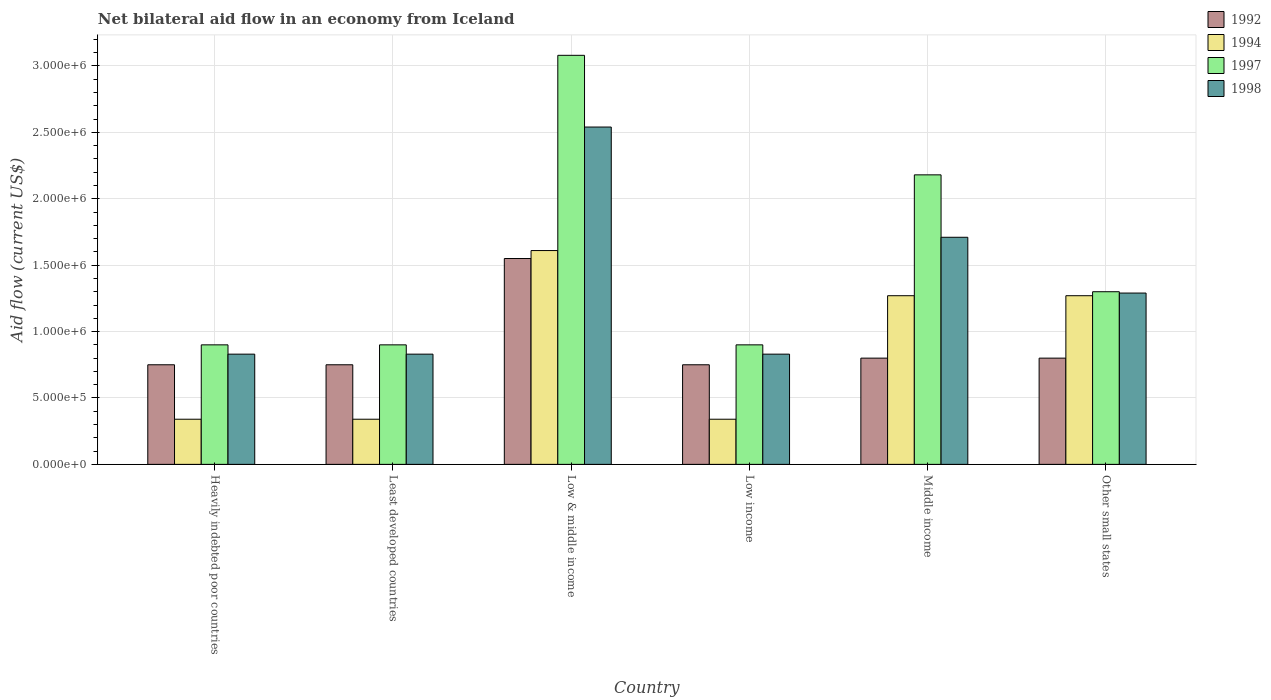How many groups of bars are there?
Your answer should be compact. 6. Are the number of bars per tick equal to the number of legend labels?
Offer a very short reply. Yes. How many bars are there on the 3rd tick from the left?
Your answer should be very brief. 4. What is the label of the 6th group of bars from the left?
Ensure brevity in your answer.  Other small states. What is the net bilateral aid flow in 1994 in Low income?
Make the answer very short. 3.40e+05. Across all countries, what is the maximum net bilateral aid flow in 1998?
Offer a very short reply. 2.54e+06. Across all countries, what is the minimum net bilateral aid flow in 1998?
Your response must be concise. 8.30e+05. In which country was the net bilateral aid flow in 1994 maximum?
Provide a short and direct response. Low & middle income. In which country was the net bilateral aid flow in 1997 minimum?
Keep it short and to the point. Heavily indebted poor countries. What is the total net bilateral aid flow in 1994 in the graph?
Offer a terse response. 5.17e+06. What is the difference between the net bilateral aid flow in 1992 in Heavily indebted poor countries and that in Other small states?
Offer a terse response. -5.00e+04. What is the difference between the net bilateral aid flow in 1997 in Low & middle income and the net bilateral aid flow in 1992 in Least developed countries?
Make the answer very short. 2.33e+06. What is the average net bilateral aid flow in 1997 per country?
Provide a short and direct response. 1.54e+06. What is the difference between the net bilateral aid flow of/in 1994 and net bilateral aid flow of/in 1997 in Low & middle income?
Provide a succinct answer. -1.47e+06. In how many countries, is the net bilateral aid flow in 1998 greater than 200000 US$?
Your response must be concise. 6. What is the ratio of the net bilateral aid flow in 1994 in Heavily indebted poor countries to that in Low & middle income?
Your answer should be very brief. 0.21. Is the difference between the net bilateral aid flow in 1994 in Least developed countries and Low & middle income greater than the difference between the net bilateral aid flow in 1997 in Least developed countries and Low & middle income?
Provide a short and direct response. Yes. What is the difference between the highest and the second highest net bilateral aid flow in 1997?
Your response must be concise. 1.78e+06. What is the difference between the highest and the lowest net bilateral aid flow in 1997?
Your response must be concise. 2.18e+06. In how many countries, is the net bilateral aid flow in 1997 greater than the average net bilateral aid flow in 1997 taken over all countries?
Your response must be concise. 2. Is the sum of the net bilateral aid flow in 1992 in Low income and Other small states greater than the maximum net bilateral aid flow in 1998 across all countries?
Provide a short and direct response. No. Is it the case that in every country, the sum of the net bilateral aid flow in 1992 and net bilateral aid flow in 1994 is greater than the sum of net bilateral aid flow in 1998 and net bilateral aid flow in 1997?
Make the answer very short. No. What does the 2nd bar from the right in Low income represents?
Your response must be concise. 1997. Is it the case that in every country, the sum of the net bilateral aid flow in 1994 and net bilateral aid flow in 1992 is greater than the net bilateral aid flow in 1997?
Offer a very short reply. No. How many bars are there?
Provide a short and direct response. 24. Are all the bars in the graph horizontal?
Your answer should be compact. No. What is the difference between two consecutive major ticks on the Y-axis?
Give a very brief answer. 5.00e+05. Are the values on the major ticks of Y-axis written in scientific E-notation?
Your answer should be very brief. Yes. Does the graph contain any zero values?
Provide a short and direct response. No. How are the legend labels stacked?
Provide a short and direct response. Vertical. What is the title of the graph?
Offer a terse response. Net bilateral aid flow in an economy from Iceland. Does "2002" appear as one of the legend labels in the graph?
Your answer should be very brief. No. What is the label or title of the X-axis?
Your answer should be very brief. Country. What is the Aid flow (current US$) of 1992 in Heavily indebted poor countries?
Offer a very short reply. 7.50e+05. What is the Aid flow (current US$) of 1997 in Heavily indebted poor countries?
Offer a very short reply. 9.00e+05. What is the Aid flow (current US$) in 1998 in Heavily indebted poor countries?
Offer a very short reply. 8.30e+05. What is the Aid flow (current US$) of 1992 in Least developed countries?
Your response must be concise. 7.50e+05. What is the Aid flow (current US$) in 1994 in Least developed countries?
Your answer should be compact. 3.40e+05. What is the Aid flow (current US$) in 1998 in Least developed countries?
Provide a short and direct response. 8.30e+05. What is the Aid flow (current US$) of 1992 in Low & middle income?
Make the answer very short. 1.55e+06. What is the Aid flow (current US$) in 1994 in Low & middle income?
Keep it short and to the point. 1.61e+06. What is the Aid flow (current US$) in 1997 in Low & middle income?
Ensure brevity in your answer.  3.08e+06. What is the Aid flow (current US$) in 1998 in Low & middle income?
Give a very brief answer. 2.54e+06. What is the Aid flow (current US$) of 1992 in Low income?
Give a very brief answer. 7.50e+05. What is the Aid flow (current US$) of 1994 in Low income?
Keep it short and to the point. 3.40e+05. What is the Aid flow (current US$) of 1998 in Low income?
Offer a very short reply. 8.30e+05. What is the Aid flow (current US$) of 1994 in Middle income?
Make the answer very short. 1.27e+06. What is the Aid flow (current US$) in 1997 in Middle income?
Your response must be concise. 2.18e+06. What is the Aid flow (current US$) of 1998 in Middle income?
Provide a succinct answer. 1.71e+06. What is the Aid flow (current US$) in 1994 in Other small states?
Your answer should be compact. 1.27e+06. What is the Aid flow (current US$) of 1997 in Other small states?
Offer a very short reply. 1.30e+06. What is the Aid flow (current US$) of 1998 in Other small states?
Provide a succinct answer. 1.29e+06. Across all countries, what is the maximum Aid flow (current US$) in 1992?
Your response must be concise. 1.55e+06. Across all countries, what is the maximum Aid flow (current US$) in 1994?
Your answer should be very brief. 1.61e+06. Across all countries, what is the maximum Aid flow (current US$) of 1997?
Offer a terse response. 3.08e+06. Across all countries, what is the maximum Aid flow (current US$) in 1998?
Your response must be concise. 2.54e+06. Across all countries, what is the minimum Aid flow (current US$) of 1992?
Offer a terse response. 7.50e+05. Across all countries, what is the minimum Aid flow (current US$) of 1994?
Offer a terse response. 3.40e+05. Across all countries, what is the minimum Aid flow (current US$) in 1997?
Provide a succinct answer. 9.00e+05. Across all countries, what is the minimum Aid flow (current US$) in 1998?
Keep it short and to the point. 8.30e+05. What is the total Aid flow (current US$) in 1992 in the graph?
Provide a short and direct response. 5.40e+06. What is the total Aid flow (current US$) in 1994 in the graph?
Offer a terse response. 5.17e+06. What is the total Aid flow (current US$) in 1997 in the graph?
Your response must be concise. 9.26e+06. What is the total Aid flow (current US$) of 1998 in the graph?
Give a very brief answer. 8.03e+06. What is the difference between the Aid flow (current US$) in 1994 in Heavily indebted poor countries and that in Least developed countries?
Provide a succinct answer. 0. What is the difference between the Aid flow (current US$) in 1998 in Heavily indebted poor countries and that in Least developed countries?
Give a very brief answer. 0. What is the difference between the Aid flow (current US$) of 1992 in Heavily indebted poor countries and that in Low & middle income?
Offer a terse response. -8.00e+05. What is the difference between the Aid flow (current US$) of 1994 in Heavily indebted poor countries and that in Low & middle income?
Your response must be concise. -1.27e+06. What is the difference between the Aid flow (current US$) of 1997 in Heavily indebted poor countries and that in Low & middle income?
Offer a very short reply. -2.18e+06. What is the difference between the Aid flow (current US$) in 1998 in Heavily indebted poor countries and that in Low & middle income?
Your answer should be compact. -1.71e+06. What is the difference between the Aid flow (current US$) in 1997 in Heavily indebted poor countries and that in Low income?
Offer a very short reply. 0. What is the difference between the Aid flow (current US$) of 1998 in Heavily indebted poor countries and that in Low income?
Provide a succinct answer. 0. What is the difference between the Aid flow (current US$) of 1994 in Heavily indebted poor countries and that in Middle income?
Make the answer very short. -9.30e+05. What is the difference between the Aid flow (current US$) of 1997 in Heavily indebted poor countries and that in Middle income?
Provide a succinct answer. -1.28e+06. What is the difference between the Aid flow (current US$) in 1998 in Heavily indebted poor countries and that in Middle income?
Make the answer very short. -8.80e+05. What is the difference between the Aid flow (current US$) in 1994 in Heavily indebted poor countries and that in Other small states?
Make the answer very short. -9.30e+05. What is the difference between the Aid flow (current US$) of 1997 in Heavily indebted poor countries and that in Other small states?
Your answer should be very brief. -4.00e+05. What is the difference between the Aid flow (current US$) in 1998 in Heavily indebted poor countries and that in Other small states?
Ensure brevity in your answer.  -4.60e+05. What is the difference between the Aid flow (current US$) of 1992 in Least developed countries and that in Low & middle income?
Provide a succinct answer. -8.00e+05. What is the difference between the Aid flow (current US$) of 1994 in Least developed countries and that in Low & middle income?
Make the answer very short. -1.27e+06. What is the difference between the Aid flow (current US$) of 1997 in Least developed countries and that in Low & middle income?
Provide a succinct answer. -2.18e+06. What is the difference between the Aid flow (current US$) of 1998 in Least developed countries and that in Low & middle income?
Your response must be concise. -1.71e+06. What is the difference between the Aid flow (current US$) of 1994 in Least developed countries and that in Low income?
Give a very brief answer. 0. What is the difference between the Aid flow (current US$) of 1998 in Least developed countries and that in Low income?
Keep it short and to the point. 0. What is the difference between the Aid flow (current US$) in 1994 in Least developed countries and that in Middle income?
Offer a very short reply. -9.30e+05. What is the difference between the Aid flow (current US$) in 1997 in Least developed countries and that in Middle income?
Ensure brevity in your answer.  -1.28e+06. What is the difference between the Aid flow (current US$) in 1998 in Least developed countries and that in Middle income?
Provide a succinct answer. -8.80e+05. What is the difference between the Aid flow (current US$) in 1992 in Least developed countries and that in Other small states?
Provide a succinct answer. -5.00e+04. What is the difference between the Aid flow (current US$) of 1994 in Least developed countries and that in Other small states?
Provide a short and direct response. -9.30e+05. What is the difference between the Aid flow (current US$) in 1997 in Least developed countries and that in Other small states?
Your answer should be compact. -4.00e+05. What is the difference between the Aid flow (current US$) of 1998 in Least developed countries and that in Other small states?
Offer a terse response. -4.60e+05. What is the difference between the Aid flow (current US$) in 1992 in Low & middle income and that in Low income?
Ensure brevity in your answer.  8.00e+05. What is the difference between the Aid flow (current US$) in 1994 in Low & middle income and that in Low income?
Make the answer very short. 1.27e+06. What is the difference between the Aid flow (current US$) in 1997 in Low & middle income and that in Low income?
Make the answer very short. 2.18e+06. What is the difference between the Aid flow (current US$) of 1998 in Low & middle income and that in Low income?
Your answer should be compact. 1.71e+06. What is the difference between the Aid flow (current US$) in 1992 in Low & middle income and that in Middle income?
Keep it short and to the point. 7.50e+05. What is the difference between the Aid flow (current US$) in 1994 in Low & middle income and that in Middle income?
Keep it short and to the point. 3.40e+05. What is the difference between the Aid flow (current US$) in 1997 in Low & middle income and that in Middle income?
Your answer should be compact. 9.00e+05. What is the difference between the Aid flow (current US$) of 1998 in Low & middle income and that in Middle income?
Your answer should be very brief. 8.30e+05. What is the difference between the Aid flow (current US$) of 1992 in Low & middle income and that in Other small states?
Your answer should be compact. 7.50e+05. What is the difference between the Aid flow (current US$) of 1994 in Low & middle income and that in Other small states?
Offer a terse response. 3.40e+05. What is the difference between the Aid flow (current US$) in 1997 in Low & middle income and that in Other small states?
Provide a short and direct response. 1.78e+06. What is the difference between the Aid flow (current US$) of 1998 in Low & middle income and that in Other small states?
Make the answer very short. 1.25e+06. What is the difference between the Aid flow (current US$) of 1992 in Low income and that in Middle income?
Ensure brevity in your answer.  -5.00e+04. What is the difference between the Aid flow (current US$) of 1994 in Low income and that in Middle income?
Your answer should be very brief. -9.30e+05. What is the difference between the Aid flow (current US$) of 1997 in Low income and that in Middle income?
Provide a succinct answer. -1.28e+06. What is the difference between the Aid flow (current US$) in 1998 in Low income and that in Middle income?
Give a very brief answer. -8.80e+05. What is the difference between the Aid flow (current US$) of 1994 in Low income and that in Other small states?
Offer a terse response. -9.30e+05. What is the difference between the Aid flow (current US$) in 1997 in Low income and that in Other small states?
Make the answer very short. -4.00e+05. What is the difference between the Aid flow (current US$) of 1998 in Low income and that in Other small states?
Provide a succinct answer. -4.60e+05. What is the difference between the Aid flow (current US$) of 1992 in Middle income and that in Other small states?
Your response must be concise. 0. What is the difference between the Aid flow (current US$) of 1997 in Middle income and that in Other small states?
Offer a terse response. 8.80e+05. What is the difference between the Aid flow (current US$) of 1994 in Heavily indebted poor countries and the Aid flow (current US$) of 1997 in Least developed countries?
Provide a short and direct response. -5.60e+05. What is the difference between the Aid flow (current US$) of 1994 in Heavily indebted poor countries and the Aid flow (current US$) of 1998 in Least developed countries?
Provide a succinct answer. -4.90e+05. What is the difference between the Aid flow (current US$) in 1992 in Heavily indebted poor countries and the Aid flow (current US$) in 1994 in Low & middle income?
Keep it short and to the point. -8.60e+05. What is the difference between the Aid flow (current US$) of 1992 in Heavily indebted poor countries and the Aid flow (current US$) of 1997 in Low & middle income?
Your response must be concise. -2.33e+06. What is the difference between the Aid flow (current US$) in 1992 in Heavily indebted poor countries and the Aid flow (current US$) in 1998 in Low & middle income?
Keep it short and to the point. -1.79e+06. What is the difference between the Aid flow (current US$) of 1994 in Heavily indebted poor countries and the Aid flow (current US$) of 1997 in Low & middle income?
Your answer should be compact. -2.74e+06. What is the difference between the Aid flow (current US$) in 1994 in Heavily indebted poor countries and the Aid flow (current US$) in 1998 in Low & middle income?
Make the answer very short. -2.20e+06. What is the difference between the Aid flow (current US$) of 1997 in Heavily indebted poor countries and the Aid flow (current US$) of 1998 in Low & middle income?
Ensure brevity in your answer.  -1.64e+06. What is the difference between the Aid flow (current US$) of 1992 in Heavily indebted poor countries and the Aid flow (current US$) of 1997 in Low income?
Offer a terse response. -1.50e+05. What is the difference between the Aid flow (current US$) of 1992 in Heavily indebted poor countries and the Aid flow (current US$) of 1998 in Low income?
Offer a very short reply. -8.00e+04. What is the difference between the Aid flow (current US$) of 1994 in Heavily indebted poor countries and the Aid flow (current US$) of 1997 in Low income?
Your answer should be very brief. -5.60e+05. What is the difference between the Aid flow (current US$) in 1994 in Heavily indebted poor countries and the Aid flow (current US$) in 1998 in Low income?
Keep it short and to the point. -4.90e+05. What is the difference between the Aid flow (current US$) in 1997 in Heavily indebted poor countries and the Aid flow (current US$) in 1998 in Low income?
Your answer should be compact. 7.00e+04. What is the difference between the Aid flow (current US$) of 1992 in Heavily indebted poor countries and the Aid flow (current US$) of 1994 in Middle income?
Provide a succinct answer. -5.20e+05. What is the difference between the Aid flow (current US$) of 1992 in Heavily indebted poor countries and the Aid flow (current US$) of 1997 in Middle income?
Your answer should be compact. -1.43e+06. What is the difference between the Aid flow (current US$) of 1992 in Heavily indebted poor countries and the Aid flow (current US$) of 1998 in Middle income?
Your response must be concise. -9.60e+05. What is the difference between the Aid flow (current US$) of 1994 in Heavily indebted poor countries and the Aid flow (current US$) of 1997 in Middle income?
Your answer should be very brief. -1.84e+06. What is the difference between the Aid flow (current US$) in 1994 in Heavily indebted poor countries and the Aid flow (current US$) in 1998 in Middle income?
Make the answer very short. -1.37e+06. What is the difference between the Aid flow (current US$) of 1997 in Heavily indebted poor countries and the Aid flow (current US$) of 1998 in Middle income?
Give a very brief answer. -8.10e+05. What is the difference between the Aid flow (current US$) in 1992 in Heavily indebted poor countries and the Aid flow (current US$) in 1994 in Other small states?
Provide a short and direct response. -5.20e+05. What is the difference between the Aid flow (current US$) in 1992 in Heavily indebted poor countries and the Aid flow (current US$) in 1997 in Other small states?
Keep it short and to the point. -5.50e+05. What is the difference between the Aid flow (current US$) in 1992 in Heavily indebted poor countries and the Aid flow (current US$) in 1998 in Other small states?
Your response must be concise. -5.40e+05. What is the difference between the Aid flow (current US$) of 1994 in Heavily indebted poor countries and the Aid flow (current US$) of 1997 in Other small states?
Offer a terse response. -9.60e+05. What is the difference between the Aid flow (current US$) in 1994 in Heavily indebted poor countries and the Aid flow (current US$) in 1998 in Other small states?
Make the answer very short. -9.50e+05. What is the difference between the Aid flow (current US$) in 1997 in Heavily indebted poor countries and the Aid flow (current US$) in 1998 in Other small states?
Make the answer very short. -3.90e+05. What is the difference between the Aid flow (current US$) in 1992 in Least developed countries and the Aid flow (current US$) in 1994 in Low & middle income?
Provide a succinct answer. -8.60e+05. What is the difference between the Aid flow (current US$) in 1992 in Least developed countries and the Aid flow (current US$) in 1997 in Low & middle income?
Keep it short and to the point. -2.33e+06. What is the difference between the Aid flow (current US$) in 1992 in Least developed countries and the Aid flow (current US$) in 1998 in Low & middle income?
Provide a succinct answer. -1.79e+06. What is the difference between the Aid flow (current US$) of 1994 in Least developed countries and the Aid flow (current US$) of 1997 in Low & middle income?
Your answer should be compact. -2.74e+06. What is the difference between the Aid flow (current US$) in 1994 in Least developed countries and the Aid flow (current US$) in 1998 in Low & middle income?
Provide a succinct answer. -2.20e+06. What is the difference between the Aid flow (current US$) in 1997 in Least developed countries and the Aid flow (current US$) in 1998 in Low & middle income?
Your response must be concise. -1.64e+06. What is the difference between the Aid flow (current US$) of 1992 in Least developed countries and the Aid flow (current US$) of 1997 in Low income?
Make the answer very short. -1.50e+05. What is the difference between the Aid flow (current US$) in 1992 in Least developed countries and the Aid flow (current US$) in 1998 in Low income?
Your answer should be very brief. -8.00e+04. What is the difference between the Aid flow (current US$) in 1994 in Least developed countries and the Aid flow (current US$) in 1997 in Low income?
Give a very brief answer. -5.60e+05. What is the difference between the Aid flow (current US$) in 1994 in Least developed countries and the Aid flow (current US$) in 1998 in Low income?
Make the answer very short. -4.90e+05. What is the difference between the Aid flow (current US$) of 1992 in Least developed countries and the Aid flow (current US$) of 1994 in Middle income?
Give a very brief answer. -5.20e+05. What is the difference between the Aid flow (current US$) of 1992 in Least developed countries and the Aid flow (current US$) of 1997 in Middle income?
Your answer should be very brief. -1.43e+06. What is the difference between the Aid flow (current US$) in 1992 in Least developed countries and the Aid flow (current US$) in 1998 in Middle income?
Provide a short and direct response. -9.60e+05. What is the difference between the Aid flow (current US$) of 1994 in Least developed countries and the Aid flow (current US$) of 1997 in Middle income?
Your answer should be compact. -1.84e+06. What is the difference between the Aid flow (current US$) of 1994 in Least developed countries and the Aid flow (current US$) of 1998 in Middle income?
Keep it short and to the point. -1.37e+06. What is the difference between the Aid flow (current US$) in 1997 in Least developed countries and the Aid flow (current US$) in 1998 in Middle income?
Your response must be concise. -8.10e+05. What is the difference between the Aid flow (current US$) of 1992 in Least developed countries and the Aid flow (current US$) of 1994 in Other small states?
Give a very brief answer. -5.20e+05. What is the difference between the Aid flow (current US$) of 1992 in Least developed countries and the Aid flow (current US$) of 1997 in Other small states?
Give a very brief answer. -5.50e+05. What is the difference between the Aid flow (current US$) in 1992 in Least developed countries and the Aid flow (current US$) in 1998 in Other small states?
Your response must be concise. -5.40e+05. What is the difference between the Aid flow (current US$) in 1994 in Least developed countries and the Aid flow (current US$) in 1997 in Other small states?
Offer a very short reply. -9.60e+05. What is the difference between the Aid flow (current US$) in 1994 in Least developed countries and the Aid flow (current US$) in 1998 in Other small states?
Keep it short and to the point. -9.50e+05. What is the difference between the Aid flow (current US$) in 1997 in Least developed countries and the Aid flow (current US$) in 1998 in Other small states?
Your answer should be very brief. -3.90e+05. What is the difference between the Aid flow (current US$) of 1992 in Low & middle income and the Aid flow (current US$) of 1994 in Low income?
Give a very brief answer. 1.21e+06. What is the difference between the Aid flow (current US$) in 1992 in Low & middle income and the Aid flow (current US$) in 1997 in Low income?
Provide a succinct answer. 6.50e+05. What is the difference between the Aid flow (current US$) of 1992 in Low & middle income and the Aid flow (current US$) of 1998 in Low income?
Make the answer very short. 7.20e+05. What is the difference between the Aid flow (current US$) in 1994 in Low & middle income and the Aid flow (current US$) in 1997 in Low income?
Your response must be concise. 7.10e+05. What is the difference between the Aid flow (current US$) of 1994 in Low & middle income and the Aid flow (current US$) of 1998 in Low income?
Offer a terse response. 7.80e+05. What is the difference between the Aid flow (current US$) in 1997 in Low & middle income and the Aid flow (current US$) in 1998 in Low income?
Provide a short and direct response. 2.25e+06. What is the difference between the Aid flow (current US$) of 1992 in Low & middle income and the Aid flow (current US$) of 1997 in Middle income?
Your response must be concise. -6.30e+05. What is the difference between the Aid flow (current US$) of 1992 in Low & middle income and the Aid flow (current US$) of 1998 in Middle income?
Offer a terse response. -1.60e+05. What is the difference between the Aid flow (current US$) in 1994 in Low & middle income and the Aid flow (current US$) in 1997 in Middle income?
Your response must be concise. -5.70e+05. What is the difference between the Aid flow (current US$) of 1994 in Low & middle income and the Aid flow (current US$) of 1998 in Middle income?
Make the answer very short. -1.00e+05. What is the difference between the Aid flow (current US$) in 1997 in Low & middle income and the Aid flow (current US$) in 1998 in Middle income?
Keep it short and to the point. 1.37e+06. What is the difference between the Aid flow (current US$) in 1992 in Low & middle income and the Aid flow (current US$) in 1994 in Other small states?
Provide a succinct answer. 2.80e+05. What is the difference between the Aid flow (current US$) of 1992 in Low & middle income and the Aid flow (current US$) of 1998 in Other small states?
Your answer should be compact. 2.60e+05. What is the difference between the Aid flow (current US$) in 1994 in Low & middle income and the Aid flow (current US$) in 1997 in Other small states?
Offer a terse response. 3.10e+05. What is the difference between the Aid flow (current US$) in 1997 in Low & middle income and the Aid flow (current US$) in 1998 in Other small states?
Make the answer very short. 1.79e+06. What is the difference between the Aid flow (current US$) of 1992 in Low income and the Aid flow (current US$) of 1994 in Middle income?
Ensure brevity in your answer.  -5.20e+05. What is the difference between the Aid flow (current US$) of 1992 in Low income and the Aid flow (current US$) of 1997 in Middle income?
Offer a very short reply. -1.43e+06. What is the difference between the Aid flow (current US$) in 1992 in Low income and the Aid flow (current US$) in 1998 in Middle income?
Offer a very short reply. -9.60e+05. What is the difference between the Aid flow (current US$) in 1994 in Low income and the Aid flow (current US$) in 1997 in Middle income?
Make the answer very short. -1.84e+06. What is the difference between the Aid flow (current US$) of 1994 in Low income and the Aid flow (current US$) of 1998 in Middle income?
Give a very brief answer. -1.37e+06. What is the difference between the Aid flow (current US$) of 1997 in Low income and the Aid flow (current US$) of 1998 in Middle income?
Ensure brevity in your answer.  -8.10e+05. What is the difference between the Aid flow (current US$) of 1992 in Low income and the Aid flow (current US$) of 1994 in Other small states?
Provide a succinct answer. -5.20e+05. What is the difference between the Aid flow (current US$) in 1992 in Low income and the Aid flow (current US$) in 1997 in Other small states?
Your response must be concise. -5.50e+05. What is the difference between the Aid flow (current US$) of 1992 in Low income and the Aid flow (current US$) of 1998 in Other small states?
Give a very brief answer. -5.40e+05. What is the difference between the Aid flow (current US$) of 1994 in Low income and the Aid flow (current US$) of 1997 in Other small states?
Give a very brief answer. -9.60e+05. What is the difference between the Aid flow (current US$) of 1994 in Low income and the Aid flow (current US$) of 1998 in Other small states?
Your response must be concise. -9.50e+05. What is the difference between the Aid flow (current US$) of 1997 in Low income and the Aid flow (current US$) of 1998 in Other small states?
Offer a terse response. -3.90e+05. What is the difference between the Aid flow (current US$) in 1992 in Middle income and the Aid flow (current US$) in 1994 in Other small states?
Ensure brevity in your answer.  -4.70e+05. What is the difference between the Aid flow (current US$) in 1992 in Middle income and the Aid flow (current US$) in 1997 in Other small states?
Your response must be concise. -5.00e+05. What is the difference between the Aid flow (current US$) in 1992 in Middle income and the Aid flow (current US$) in 1998 in Other small states?
Your response must be concise. -4.90e+05. What is the difference between the Aid flow (current US$) in 1994 in Middle income and the Aid flow (current US$) in 1998 in Other small states?
Provide a short and direct response. -2.00e+04. What is the difference between the Aid flow (current US$) in 1997 in Middle income and the Aid flow (current US$) in 1998 in Other small states?
Make the answer very short. 8.90e+05. What is the average Aid flow (current US$) of 1994 per country?
Your answer should be very brief. 8.62e+05. What is the average Aid flow (current US$) in 1997 per country?
Keep it short and to the point. 1.54e+06. What is the average Aid flow (current US$) in 1998 per country?
Offer a very short reply. 1.34e+06. What is the difference between the Aid flow (current US$) in 1992 and Aid flow (current US$) in 1998 in Heavily indebted poor countries?
Give a very brief answer. -8.00e+04. What is the difference between the Aid flow (current US$) of 1994 and Aid flow (current US$) of 1997 in Heavily indebted poor countries?
Your answer should be very brief. -5.60e+05. What is the difference between the Aid flow (current US$) in 1994 and Aid flow (current US$) in 1998 in Heavily indebted poor countries?
Your answer should be very brief. -4.90e+05. What is the difference between the Aid flow (current US$) in 1997 and Aid flow (current US$) in 1998 in Heavily indebted poor countries?
Provide a short and direct response. 7.00e+04. What is the difference between the Aid flow (current US$) in 1992 and Aid flow (current US$) in 1994 in Least developed countries?
Offer a terse response. 4.10e+05. What is the difference between the Aid flow (current US$) of 1992 and Aid flow (current US$) of 1997 in Least developed countries?
Provide a succinct answer. -1.50e+05. What is the difference between the Aid flow (current US$) of 1992 and Aid flow (current US$) of 1998 in Least developed countries?
Keep it short and to the point. -8.00e+04. What is the difference between the Aid flow (current US$) in 1994 and Aid flow (current US$) in 1997 in Least developed countries?
Offer a very short reply. -5.60e+05. What is the difference between the Aid flow (current US$) of 1994 and Aid flow (current US$) of 1998 in Least developed countries?
Your answer should be very brief. -4.90e+05. What is the difference between the Aid flow (current US$) of 1997 and Aid flow (current US$) of 1998 in Least developed countries?
Your answer should be very brief. 7.00e+04. What is the difference between the Aid flow (current US$) in 1992 and Aid flow (current US$) in 1994 in Low & middle income?
Provide a short and direct response. -6.00e+04. What is the difference between the Aid flow (current US$) of 1992 and Aid flow (current US$) of 1997 in Low & middle income?
Offer a very short reply. -1.53e+06. What is the difference between the Aid flow (current US$) in 1992 and Aid flow (current US$) in 1998 in Low & middle income?
Ensure brevity in your answer.  -9.90e+05. What is the difference between the Aid flow (current US$) in 1994 and Aid flow (current US$) in 1997 in Low & middle income?
Give a very brief answer. -1.47e+06. What is the difference between the Aid flow (current US$) in 1994 and Aid flow (current US$) in 1998 in Low & middle income?
Your response must be concise. -9.30e+05. What is the difference between the Aid flow (current US$) in 1997 and Aid flow (current US$) in 1998 in Low & middle income?
Keep it short and to the point. 5.40e+05. What is the difference between the Aid flow (current US$) in 1992 and Aid flow (current US$) in 1994 in Low income?
Your answer should be very brief. 4.10e+05. What is the difference between the Aid flow (current US$) in 1992 and Aid flow (current US$) in 1997 in Low income?
Offer a terse response. -1.50e+05. What is the difference between the Aid flow (current US$) of 1994 and Aid flow (current US$) of 1997 in Low income?
Provide a short and direct response. -5.60e+05. What is the difference between the Aid flow (current US$) of 1994 and Aid flow (current US$) of 1998 in Low income?
Your answer should be compact. -4.90e+05. What is the difference between the Aid flow (current US$) of 1997 and Aid flow (current US$) of 1998 in Low income?
Your answer should be very brief. 7.00e+04. What is the difference between the Aid flow (current US$) of 1992 and Aid flow (current US$) of 1994 in Middle income?
Your answer should be compact. -4.70e+05. What is the difference between the Aid flow (current US$) of 1992 and Aid flow (current US$) of 1997 in Middle income?
Your response must be concise. -1.38e+06. What is the difference between the Aid flow (current US$) in 1992 and Aid flow (current US$) in 1998 in Middle income?
Your response must be concise. -9.10e+05. What is the difference between the Aid flow (current US$) of 1994 and Aid flow (current US$) of 1997 in Middle income?
Make the answer very short. -9.10e+05. What is the difference between the Aid flow (current US$) in 1994 and Aid flow (current US$) in 1998 in Middle income?
Offer a very short reply. -4.40e+05. What is the difference between the Aid flow (current US$) in 1992 and Aid flow (current US$) in 1994 in Other small states?
Provide a succinct answer. -4.70e+05. What is the difference between the Aid flow (current US$) of 1992 and Aid flow (current US$) of 1997 in Other small states?
Provide a short and direct response. -5.00e+05. What is the difference between the Aid flow (current US$) of 1992 and Aid flow (current US$) of 1998 in Other small states?
Ensure brevity in your answer.  -4.90e+05. What is the difference between the Aid flow (current US$) in 1997 and Aid flow (current US$) in 1998 in Other small states?
Your response must be concise. 10000. What is the ratio of the Aid flow (current US$) in 1992 in Heavily indebted poor countries to that in Least developed countries?
Make the answer very short. 1. What is the ratio of the Aid flow (current US$) in 1994 in Heavily indebted poor countries to that in Least developed countries?
Offer a terse response. 1. What is the ratio of the Aid flow (current US$) in 1992 in Heavily indebted poor countries to that in Low & middle income?
Your answer should be compact. 0.48. What is the ratio of the Aid flow (current US$) of 1994 in Heavily indebted poor countries to that in Low & middle income?
Offer a very short reply. 0.21. What is the ratio of the Aid flow (current US$) of 1997 in Heavily indebted poor countries to that in Low & middle income?
Make the answer very short. 0.29. What is the ratio of the Aid flow (current US$) in 1998 in Heavily indebted poor countries to that in Low & middle income?
Give a very brief answer. 0.33. What is the ratio of the Aid flow (current US$) in 1992 in Heavily indebted poor countries to that in Low income?
Your answer should be compact. 1. What is the ratio of the Aid flow (current US$) of 1997 in Heavily indebted poor countries to that in Low income?
Provide a short and direct response. 1. What is the ratio of the Aid flow (current US$) in 1994 in Heavily indebted poor countries to that in Middle income?
Make the answer very short. 0.27. What is the ratio of the Aid flow (current US$) of 1997 in Heavily indebted poor countries to that in Middle income?
Offer a very short reply. 0.41. What is the ratio of the Aid flow (current US$) in 1998 in Heavily indebted poor countries to that in Middle income?
Keep it short and to the point. 0.49. What is the ratio of the Aid flow (current US$) of 1992 in Heavily indebted poor countries to that in Other small states?
Provide a succinct answer. 0.94. What is the ratio of the Aid flow (current US$) of 1994 in Heavily indebted poor countries to that in Other small states?
Your answer should be compact. 0.27. What is the ratio of the Aid flow (current US$) of 1997 in Heavily indebted poor countries to that in Other small states?
Your answer should be compact. 0.69. What is the ratio of the Aid flow (current US$) in 1998 in Heavily indebted poor countries to that in Other small states?
Make the answer very short. 0.64. What is the ratio of the Aid flow (current US$) of 1992 in Least developed countries to that in Low & middle income?
Offer a terse response. 0.48. What is the ratio of the Aid flow (current US$) in 1994 in Least developed countries to that in Low & middle income?
Your answer should be compact. 0.21. What is the ratio of the Aid flow (current US$) in 1997 in Least developed countries to that in Low & middle income?
Provide a succinct answer. 0.29. What is the ratio of the Aid flow (current US$) of 1998 in Least developed countries to that in Low & middle income?
Your response must be concise. 0.33. What is the ratio of the Aid flow (current US$) of 1992 in Least developed countries to that in Low income?
Provide a succinct answer. 1. What is the ratio of the Aid flow (current US$) of 1997 in Least developed countries to that in Low income?
Offer a very short reply. 1. What is the ratio of the Aid flow (current US$) in 1998 in Least developed countries to that in Low income?
Your response must be concise. 1. What is the ratio of the Aid flow (current US$) of 1992 in Least developed countries to that in Middle income?
Ensure brevity in your answer.  0.94. What is the ratio of the Aid flow (current US$) in 1994 in Least developed countries to that in Middle income?
Offer a very short reply. 0.27. What is the ratio of the Aid flow (current US$) of 1997 in Least developed countries to that in Middle income?
Make the answer very short. 0.41. What is the ratio of the Aid flow (current US$) of 1998 in Least developed countries to that in Middle income?
Offer a terse response. 0.49. What is the ratio of the Aid flow (current US$) of 1994 in Least developed countries to that in Other small states?
Your answer should be very brief. 0.27. What is the ratio of the Aid flow (current US$) of 1997 in Least developed countries to that in Other small states?
Your answer should be very brief. 0.69. What is the ratio of the Aid flow (current US$) in 1998 in Least developed countries to that in Other small states?
Give a very brief answer. 0.64. What is the ratio of the Aid flow (current US$) in 1992 in Low & middle income to that in Low income?
Provide a short and direct response. 2.07. What is the ratio of the Aid flow (current US$) in 1994 in Low & middle income to that in Low income?
Give a very brief answer. 4.74. What is the ratio of the Aid flow (current US$) of 1997 in Low & middle income to that in Low income?
Make the answer very short. 3.42. What is the ratio of the Aid flow (current US$) of 1998 in Low & middle income to that in Low income?
Provide a succinct answer. 3.06. What is the ratio of the Aid flow (current US$) in 1992 in Low & middle income to that in Middle income?
Ensure brevity in your answer.  1.94. What is the ratio of the Aid flow (current US$) in 1994 in Low & middle income to that in Middle income?
Ensure brevity in your answer.  1.27. What is the ratio of the Aid flow (current US$) of 1997 in Low & middle income to that in Middle income?
Provide a short and direct response. 1.41. What is the ratio of the Aid flow (current US$) of 1998 in Low & middle income to that in Middle income?
Give a very brief answer. 1.49. What is the ratio of the Aid flow (current US$) of 1992 in Low & middle income to that in Other small states?
Offer a very short reply. 1.94. What is the ratio of the Aid flow (current US$) in 1994 in Low & middle income to that in Other small states?
Make the answer very short. 1.27. What is the ratio of the Aid flow (current US$) of 1997 in Low & middle income to that in Other small states?
Make the answer very short. 2.37. What is the ratio of the Aid flow (current US$) of 1998 in Low & middle income to that in Other small states?
Offer a terse response. 1.97. What is the ratio of the Aid flow (current US$) of 1994 in Low income to that in Middle income?
Your answer should be compact. 0.27. What is the ratio of the Aid flow (current US$) of 1997 in Low income to that in Middle income?
Provide a short and direct response. 0.41. What is the ratio of the Aid flow (current US$) in 1998 in Low income to that in Middle income?
Keep it short and to the point. 0.49. What is the ratio of the Aid flow (current US$) in 1992 in Low income to that in Other small states?
Provide a short and direct response. 0.94. What is the ratio of the Aid flow (current US$) of 1994 in Low income to that in Other small states?
Keep it short and to the point. 0.27. What is the ratio of the Aid flow (current US$) in 1997 in Low income to that in Other small states?
Keep it short and to the point. 0.69. What is the ratio of the Aid flow (current US$) in 1998 in Low income to that in Other small states?
Provide a short and direct response. 0.64. What is the ratio of the Aid flow (current US$) of 1992 in Middle income to that in Other small states?
Ensure brevity in your answer.  1. What is the ratio of the Aid flow (current US$) of 1994 in Middle income to that in Other small states?
Provide a short and direct response. 1. What is the ratio of the Aid flow (current US$) in 1997 in Middle income to that in Other small states?
Keep it short and to the point. 1.68. What is the ratio of the Aid flow (current US$) of 1998 in Middle income to that in Other small states?
Your response must be concise. 1.33. What is the difference between the highest and the second highest Aid flow (current US$) of 1992?
Make the answer very short. 7.50e+05. What is the difference between the highest and the second highest Aid flow (current US$) of 1994?
Provide a succinct answer. 3.40e+05. What is the difference between the highest and the second highest Aid flow (current US$) in 1997?
Ensure brevity in your answer.  9.00e+05. What is the difference between the highest and the second highest Aid flow (current US$) in 1998?
Offer a terse response. 8.30e+05. What is the difference between the highest and the lowest Aid flow (current US$) of 1992?
Ensure brevity in your answer.  8.00e+05. What is the difference between the highest and the lowest Aid flow (current US$) of 1994?
Offer a terse response. 1.27e+06. What is the difference between the highest and the lowest Aid flow (current US$) of 1997?
Your response must be concise. 2.18e+06. What is the difference between the highest and the lowest Aid flow (current US$) in 1998?
Ensure brevity in your answer.  1.71e+06. 